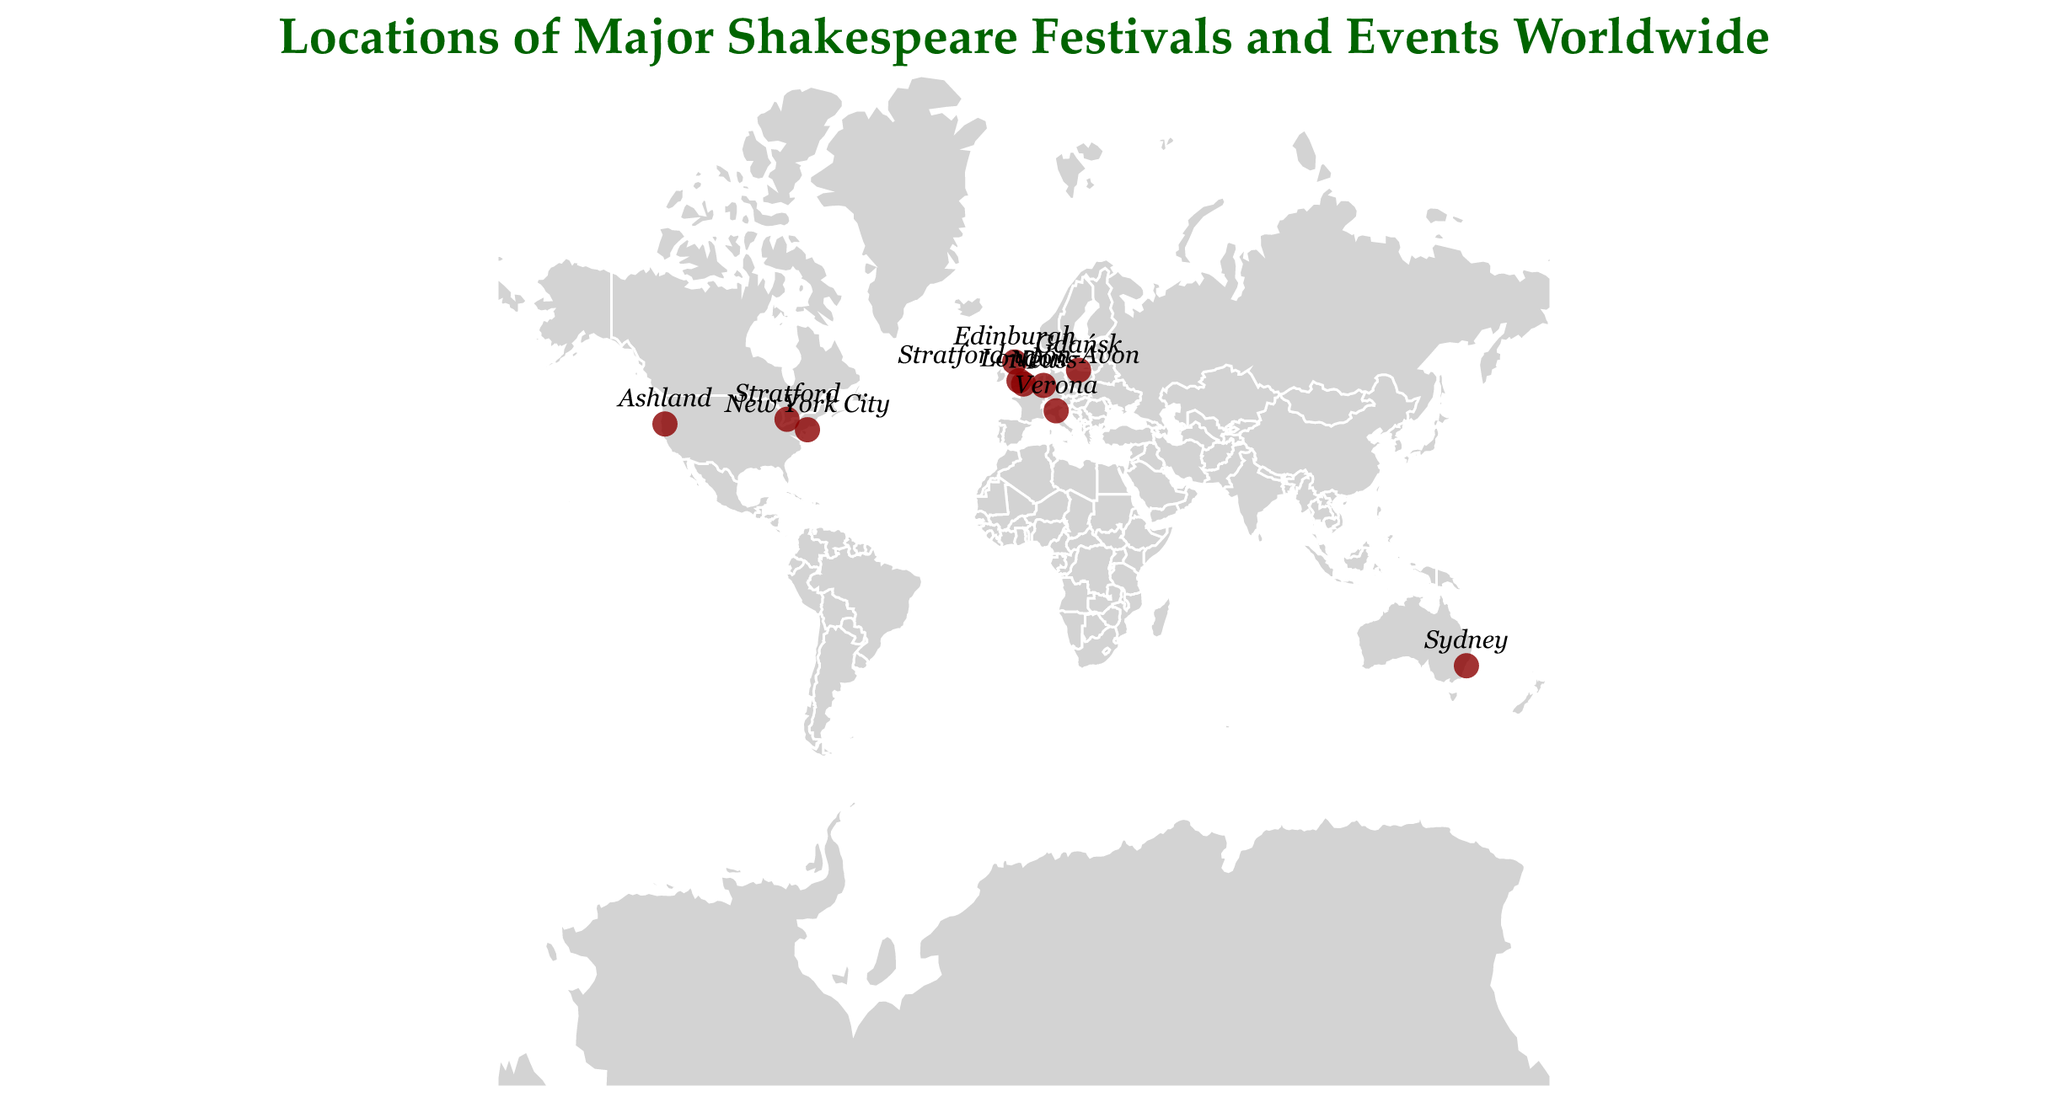Which city hosts the Royal Shakespeare Company festival? The Royal Shakespeare Company festival is hosted in Stratford-upon-Avon, as indicated next to the corresponding circle with tooltip details.
Answer: Stratford-upon-Avon What is the significance of the festival in London? The tooltip for the circle located at London states that the festival significance is "Replica of original Globe Theatre."
Answer: Replica of original Globe Theatre How many Shakespeare festivals are listed in Europe? From the map, we can observe festivals in Stratford-upon-Avon, London, Gdańsk, Neuss, Verona, and Edinburgh, which makes a total of 6 European festivals.
Answer: 6 Which festival is located furthest south? By examining the latitudinal coordinates in the map, the festival in Sydney has the most southern latitude of -33.8688.
Answer: Shakespeare by the Sea in Sydney Compare the significance of the festival in Ashland, US, and Gdańsk, Poland. The festival in Ashland is known as the largest repertory theater in the US, while the one in Gdańsk is the largest Shakespeare festival in Poland, as per the tooltip information.
Answer: Ashland: largest repertory theater in US, Gdańsk: largest Shakespeare festival in Poland Which location has the only permanent Globe replica in continental Europe? The tooltip for the circle at Neuss states this location has the only permanent Globe replica in continental Europe.
Answer: Neuss What is the latitude of the Shakespeare festival held in New York City? The latitude of New York City is given in the data as 40.7128, shown under the corresponding circle on the map.
Answer: 40.7128 Which festivals are conducted in outdoor venues with historic or scenic significance? The festivals with notable outdoor venues based on the tooltip information are Shakespeare in Verona (in a historic Roman amphitheater) and Shakespeare by the Sea in Sydney (with harbor views).
Answer: Verona and Sydney Between Neuss and Edinburgh, which festival is located further north? Comparing the latitudes, Neuss is at 51.2012 while Edinburgh is at 55.9533. Thus, Edinburgh is further north.
Answer: Edinburgh What type of geographical projection is used in the map? According to the visualization details, the projection type used is "mercator," which is a standard world map projection.
Answer: Mercator 